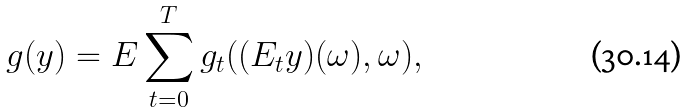Convert formula to latex. <formula><loc_0><loc_0><loc_500><loc_500>g ( y ) & = E \sum _ { t = 0 } ^ { T } g _ { t } ( ( E _ { t } y ) ( \omega ) , \omega ) ,</formula> 